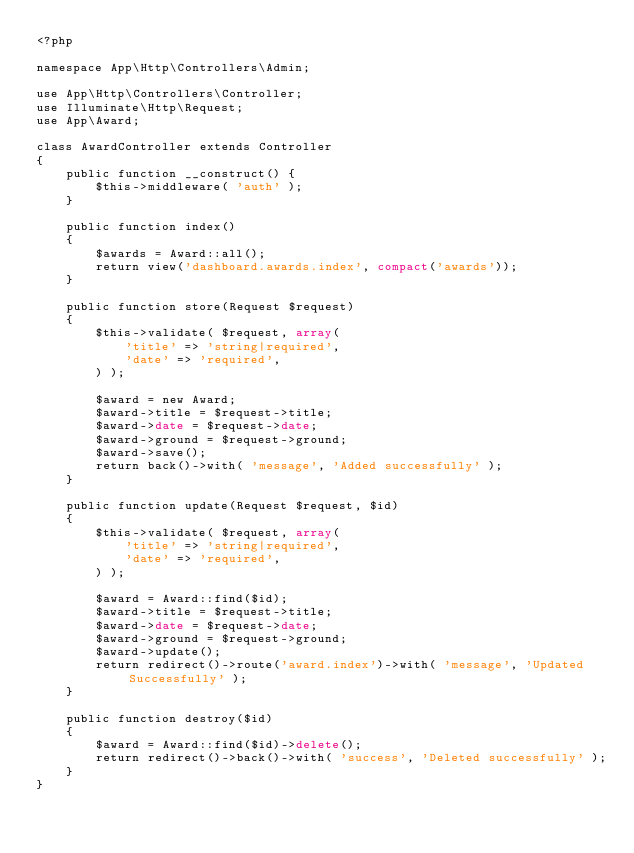Convert code to text. <code><loc_0><loc_0><loc_500><loc_500><_PHP_><?php

namespace App\Http\Controllers\Admin;

use App\Http\Controllers\Controller;
use Illuminate\Http\Request;
use App\Award;

class AwardController extends Controller
{
    public function __construct() {
        $this->middleware( 'auth' );
    }

    public function index()
    {
    	$awards = Award::all();
    	return view('dashboard.awards.index', compact('awards'));
    }

    public function store(Request $request)
    {
    	$this->validate( $request, array(
            'title' => 'string|required',
            'date' => 'required',
        ) );

        $award = new Award;
        $award->title = $request->title;
        $award->date = $request->date;
        $award->ground = $request->ground;
        $award->save();
        return back()->with( 'message', 'Added successfully' );
    }

    public function update(Request $request, $id)
    {
    	$this->validate( $request, array(
            'title' => 'string|required',
            'date' => 'required',
        ) );

        $award = Award::find($id);
        $award->title = $request->title;
        $award->date = $request->date;
        $award->ground = $request->ground;
        $award->update();
        return redirect()->route('award.index')->with( 'message', 'Updated Successfully' );
    }

    public function destroy($id)
    {
        $award = Award::find($id)->delete();
        return redirect()->back()->with( 'success', 'Deleted successfully' );
    }
}
</code> 